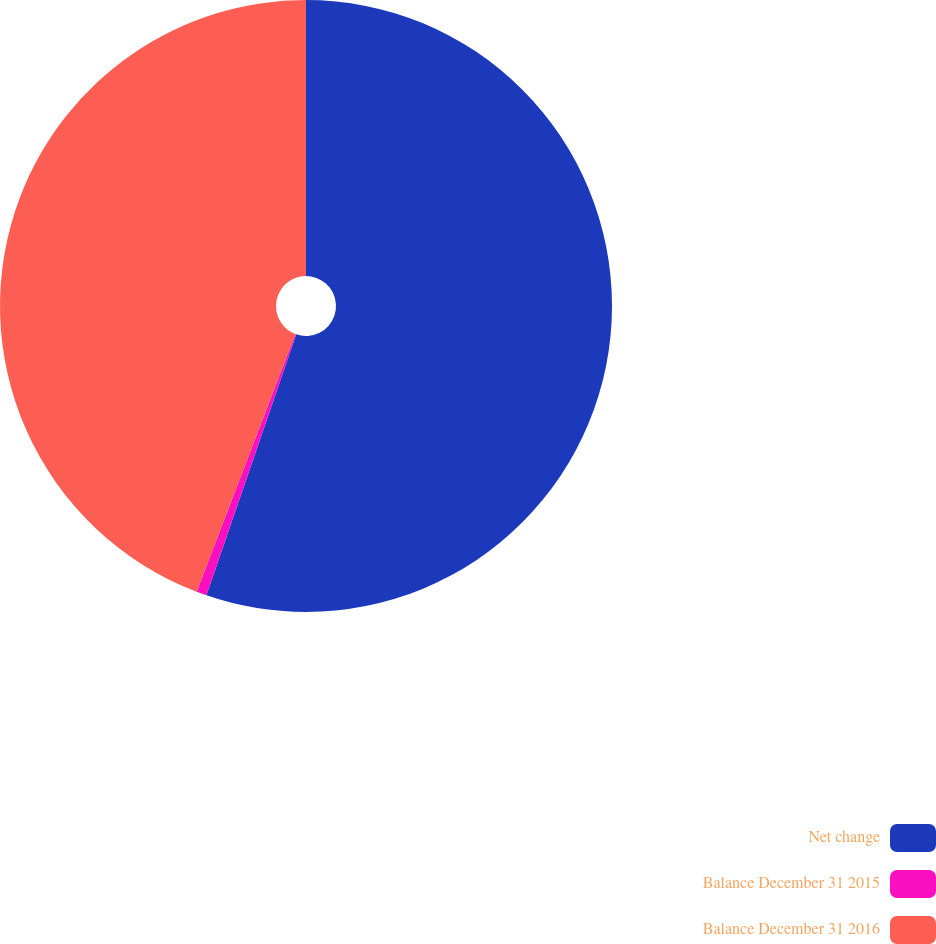Convert chart to OTSL. <chart><loc_0><loc_0><loc_500><loc_500><pie_chart><fcel>Net change<fcel>Balance December 31 2015<fcel>Balance December 31 2016<nl><fcel>55.27%<fcel>0.54%<fcel>44.18%<nl></chart> 